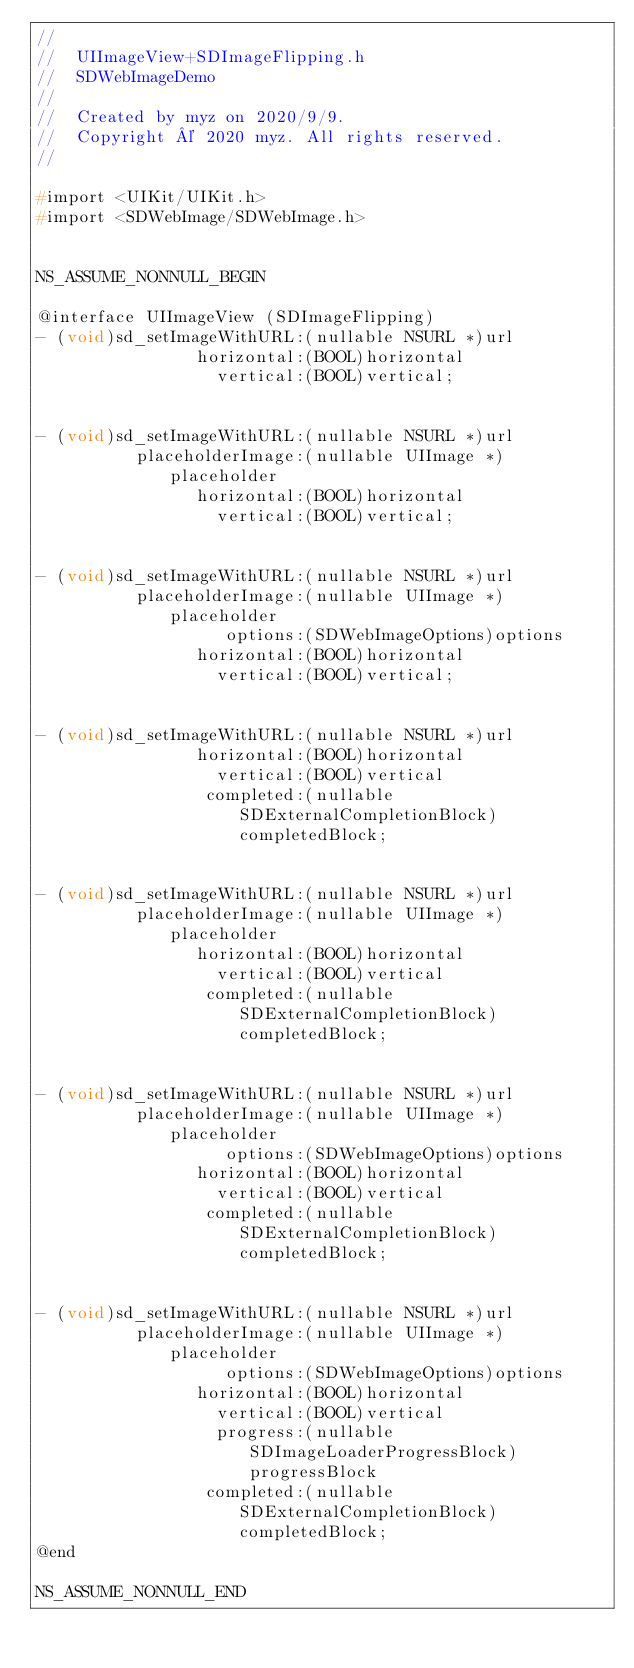Convert code to text. <code><loc_0><loc_0><loc_500><loc_500><_C_>//
//  UIImageView+SDImageFlipping.h
//  SDWebImageDemo
//
//  Created by myz on 2020/9/9.
//  Copyright © 2020 myz. All rights reserved.
//

#import <UIKit/UIKit.h>
#import <SDWebImage/SDWebImage.h>


NS_ASSUME_NONNULL_BEGIN

@interface UIImageView (SDImageFlipping)
- (void)sd_setImageWithURL:(nullable NSURL *)url
                horizontal:(BOOL)horizontal
                  vertical:(BOOL)vertical;


- (void)sd_setImageWithURL:(nullable NSURL *)url
          placeholderImage:(nullable UIImage *)placeholder
                horizontal:(BOOL)horizontal
                  vertical:(BOOL)vertical;


- (void)sd_setImageWithURL:(nullable NSURL *)url
          placeholderImage:(nullable UIImage *)placeholder
                   options:(SDWebImageOptions)options
                horizontal:(BOOL)horizontal
                  vertical:(BOOL)vertical;


- (void)sd_setImageWithURL:(nullable NSURL *)url
                horizontal:(BOOL)horizontal
                  vertical:(BOOL)vertical
                 completed:(nullable SDExternalCompletionBlock)completedBlock;


- (void)sd_setImageWithURL:(nullable NSURL *)url
          placeholderImage:(nullable UIImage *)placeholder
                horizontal:(BOOL)horizontal
                  vertical:(BOOL)vertical
                 completed:(nullable SDExternalCompletionBlock)completedBlock;


- (void)sd_setImageWithURL:(nullable NSURL *)url
          placeholderImage:(nullable UIImage *)placeholder
                   options:(SDWebImageOptions)options
                horizontal:(BOOL)horizontal
                  vertical:(BOOL)vertical
                 completed:(nullable SDExternalCompletionBlock)completedBlock;


- (void)sd_setImageWithURL:(nullable NSURL *)url
          placeholderImage:(nullable UIImage *)placeholder
                   options:(SDWebImageOptions)options
                horizontal:(BOOL)horizontal
                  vertical:(BOOL)vertical
                  progress:(nullable SDImageLoaderProgressBlock)progressBlock
                 completed:(nullable SDExternalCompletionBlock)completedBlock;
@end

NS_ASSUME_NONNULL_END
</code> 